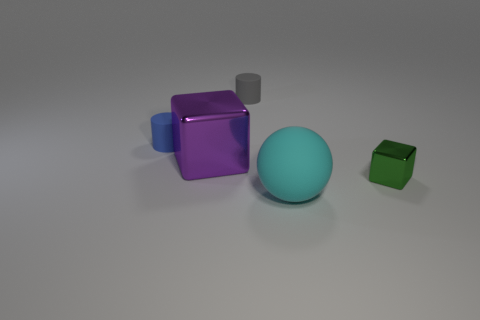Add 3 small blue rubber things. How many objects exist? 8 Subtract 1 balls. How many balls are left? 0 Subtract all small gray objects. Subtract all small green things. How many objects are left? 3 Add 4 tiny cylinders. How many tiny cylinders are left? 6 Add 2 small blue rubber cylinders. How many small blue rubber cylinders exist? 3 Subtract 0 red balls. How many objects are left? 5 Subtract all cylinders. How many objects are left? 3 Subtract all blue cylinders. Subtract all red blocks. How many cylinders are left? 1 Subtract all brown cubes. How many gray cylinders are left? 1 